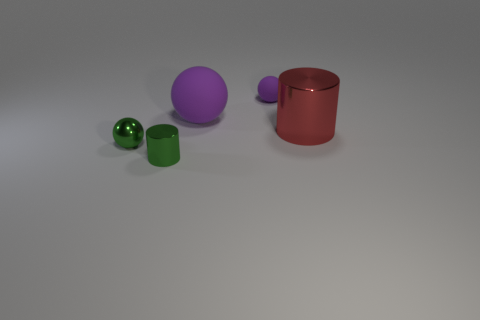Subtract all small green metallic balls. How many balls are left? 2 Add 1 big purple cubes. How many objects exist? 6 Subtract all purple balls. How many balls are left? 1 Subtract 2 balls. How many balls are left? 1 Subtract all cyan balls. How many gray cylinders are left? 0 Subtract all small balls. Subtract all big rubber objects. How many objects are left? 2 Add 3 purple objects. How many purple objects are left? 5 Add 4 red metallic cylinders. How many red metallic cylinders exist? 5 Subtract 0 cyan spheres. How many objects are left? 5 Subtract all balls. How many objects are left? 2 